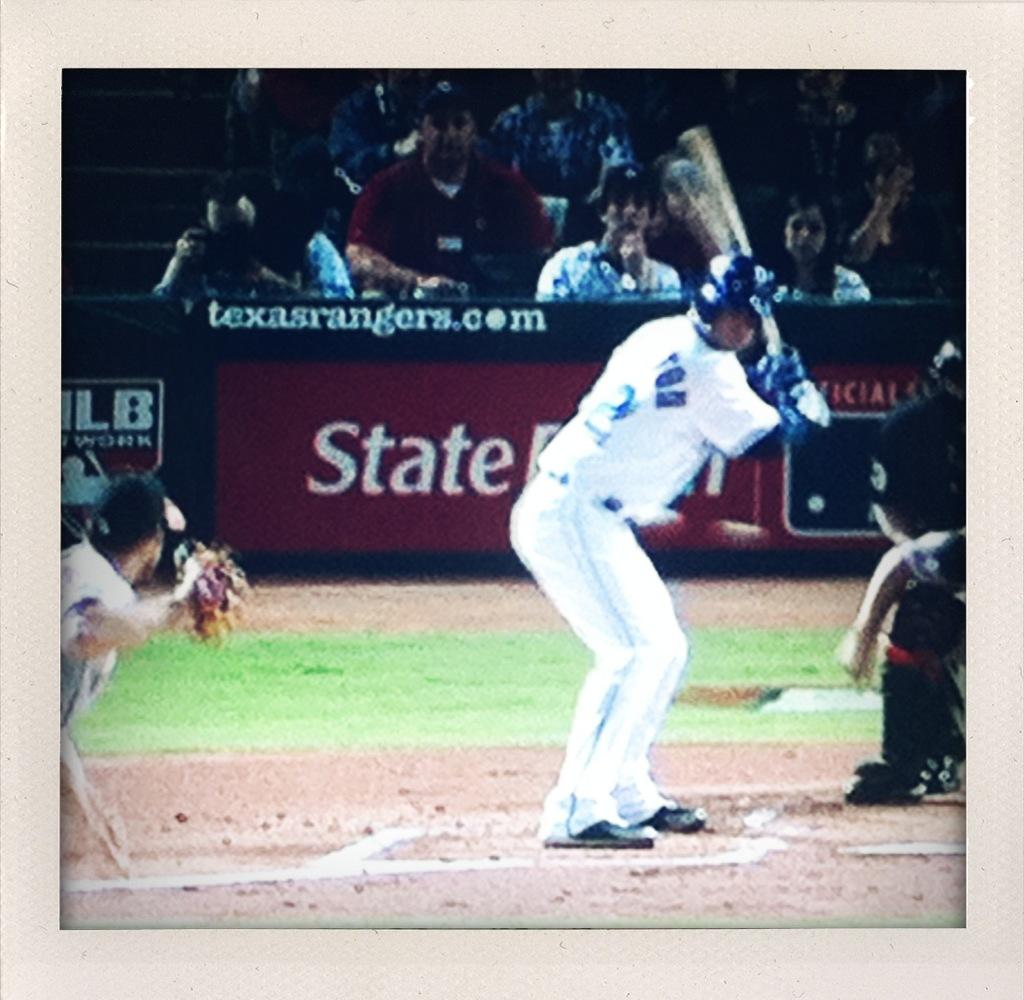<image>
Create a compact narrative representing the image presented. A man preparing to hit a baseball with a State Farm ad behind him 